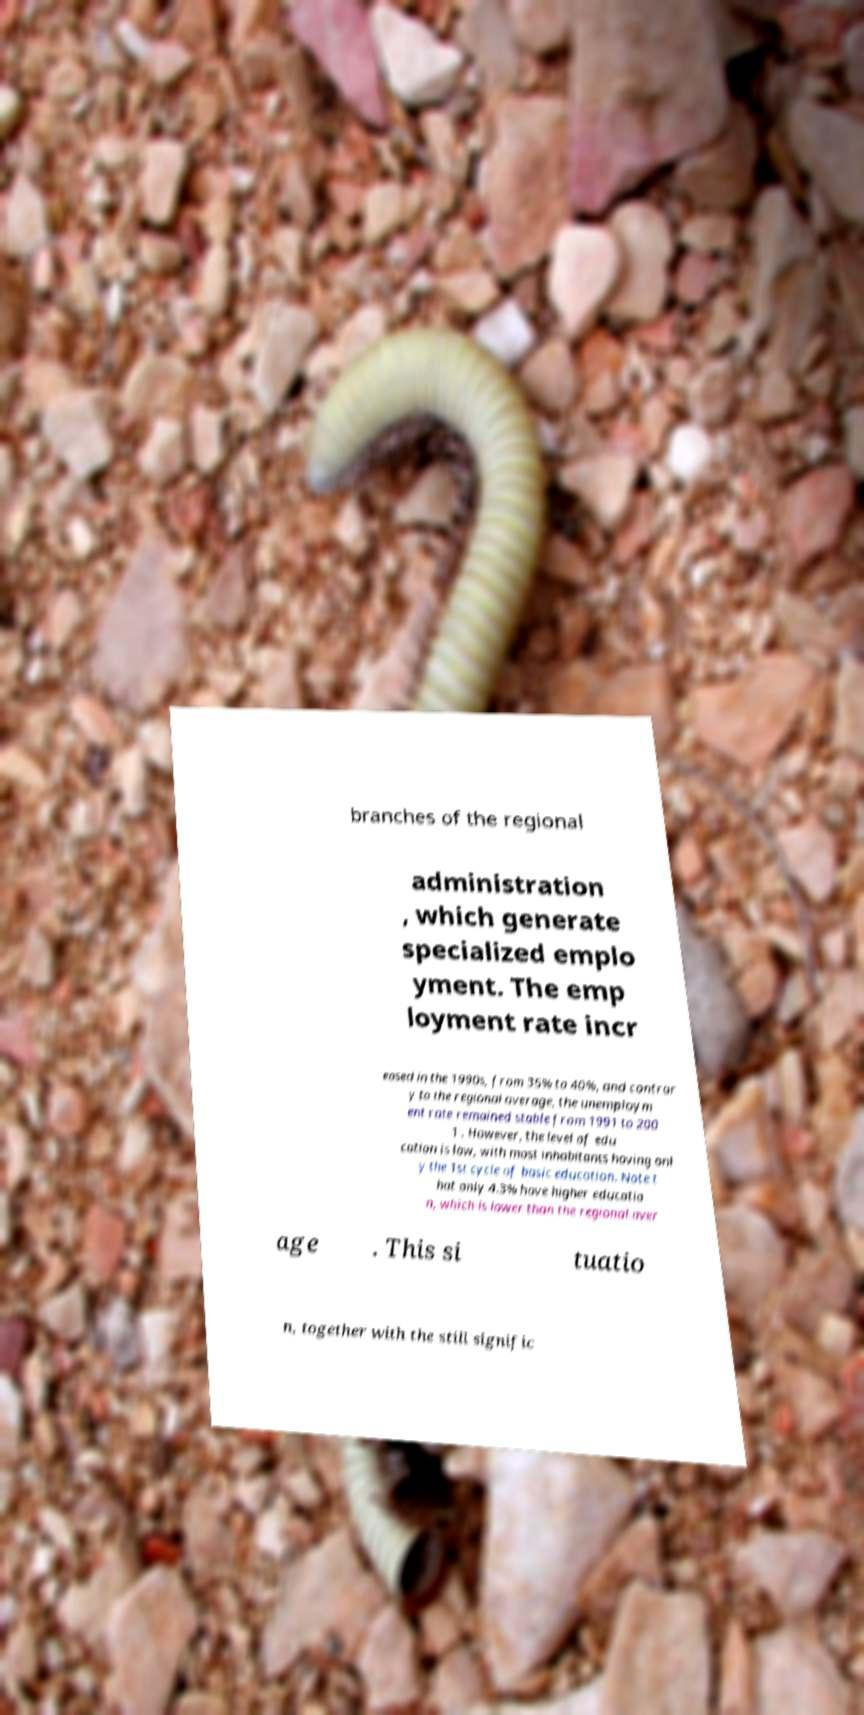Please read and relay the text visible in this image. What does it say? branches of the regional administration , which generate specialized emplo yment. The emp loyment rate incr eased in the 1990s, from 35% to 40%, and contrar y to the regional average, the unemploym ent rate remained stable from 1991 to 200 1 . However, the level of edu cation is low, with most inhabitants having onl y the 1st cycle of basic education. Note t hat only 4.3% have higher educatio n, which is lower than the regional aver age . This si tuatio n, together with the still signific 